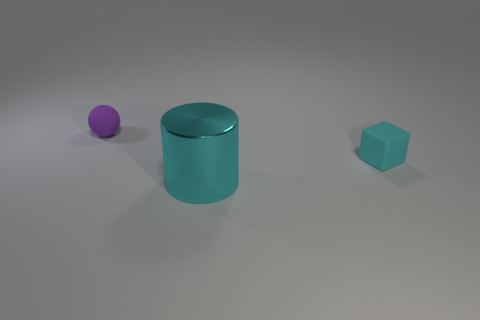Is there any other thing that is the same material as the big thing?
Offer a very short reply. No. Is there any other thing that has the same size as the cyan cylinder?
Offer a terse response. No. Are there any large things of the same color as the cube?
Provide a succinct answer. Yes. Are the large thing and the tiny object that is to the right of the tiny purple thing made of the same material?
Ensure brevity in your answer.  No. Is there a cyan shiny cylinder that is in front of the tiny matte object to the right of the large cylinder?
Ensure brevity in your answer.  Yes. There is a object that is to the right of the purple object and left of the cyan cube; what is its color?
Make the answer very short. Cyan. What is the size of the purple object?
Make the answer very short. Small. What number of other rubber things are the same size as the cyan rubber object?
Keep it short and to the point. 1. Is the material of the tiny thing that is on the left side of the small cyan rubber thing the same as the cyan thing to the left of the tiny cyan block?
Your response must be concise. No. The thing in front of the matte object to the right of the purple thing is made of what material?
Your answer should be compact. Metal. 